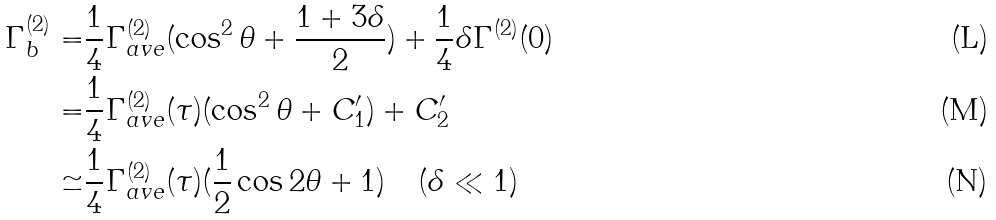Convert formula to latex. <formula><loc_0><loc_0><loc_500><loc_500>\Gamma _ { b } ^ { ( 2 ) } = & \frac { 1 } { 4 } \Gamma _ { a v e } ^ { ( 2 ) } ( \cos ^ { 2 } \theta + \frac { 1 + 3 \delta } { 2 } ) + \frac { 1 } { 4 } \delta \Gamma ^ { ( 2 ) } ( 0 ) \\ = & \frac { 1 } { 4 } \Gamma _ { a v e } ^ { ( 2 ) } ( \tau ) ( \cos ^ { 2 } \theta + C _ { 1 } ^ { \prime } ) + C _ { 2 } ^ { \prime } \\ \simeq & \frac { 1 } { 4 } \Gamma _ { a v e } ^ { ( 2 ) } ( \tau ) ( \frac { 1 } { 2 } \cos 2 \theta + 1 ) \quad ( \delta \ll 1 )</formula> 